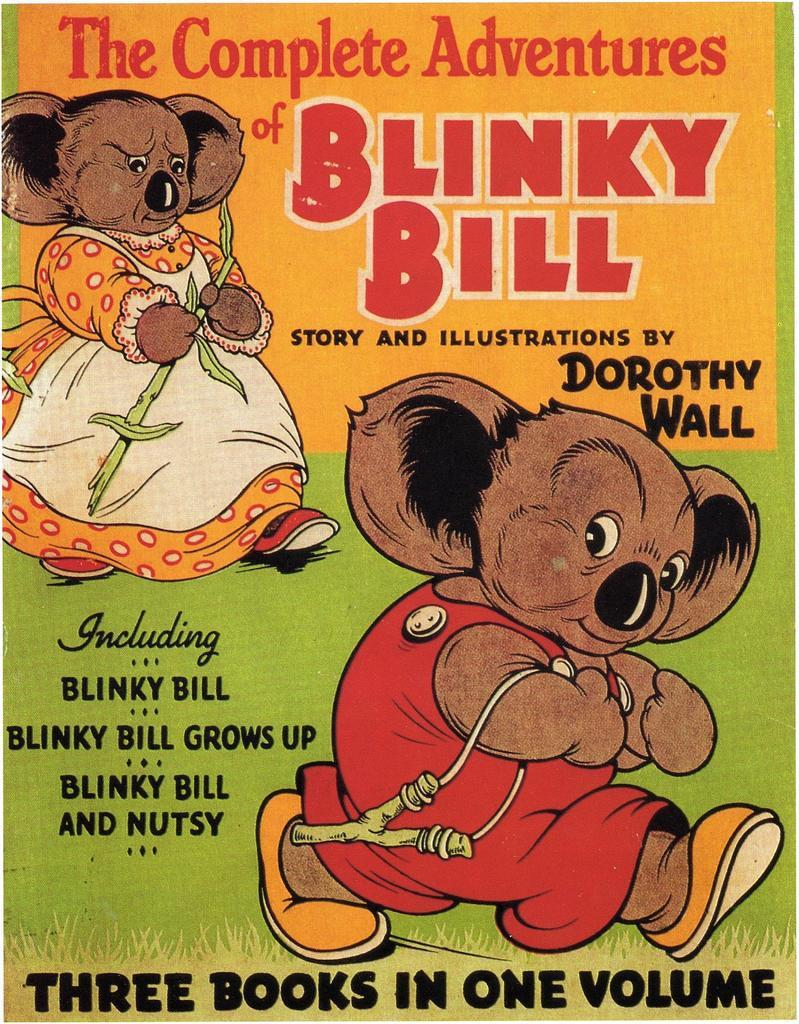What is the main subject of the image? The image shows the cover page of a book. What type of toys are depicted on the book cover? There are toys with dresses depicted on the book cover. Is there any text on the book cover? Yes, there is text written on the book cover. How would you describe the appearance of the book cover? The book cover is colorful. How many dogs are present on the book cover? There are no dogs depicted on the book cover; it features toys with dresses. What type of building is shown on the book cover? There is no building shown on the book cover; it is a cover page of a book with toys and text. 